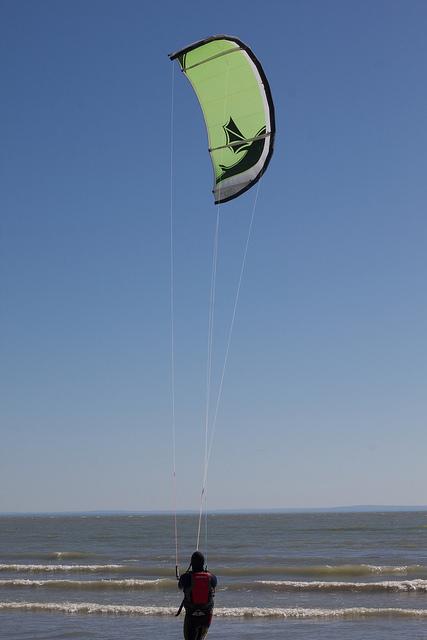Is the sky clear?
Give a very brief answer. Yes. How many people are in this photo?
Write a very short answer. 1. What color is the kite in the sky?
Answer briefly. Green. How long do you think it took this man to set up?
Answer briefly. 10 minutes. What activity is that man participating in?
Write a very short answer. Parasailing. What colors are the parachute?
Give a very brief answer. Green and black. 